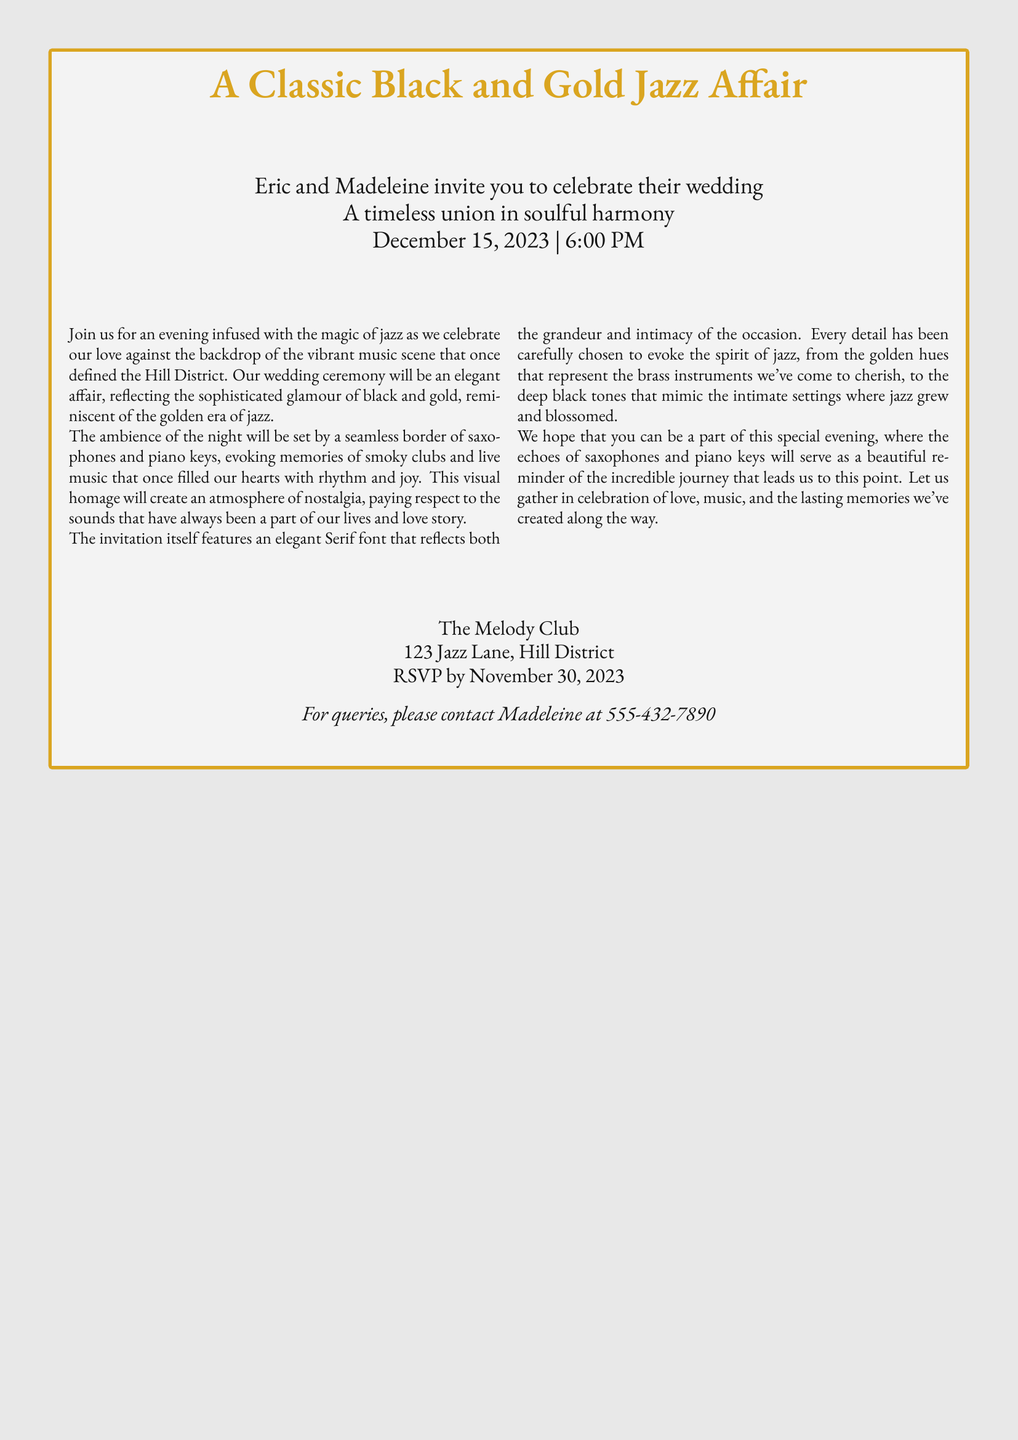What is the date of the wedding? The date of the wedding is clearly stated in the document as December 15, 2023.
Answer: December 15, 2023 Who are the hosts of the wedding? The names of the hosts are listed in the invitation, which are Eric and Madeleine.
Answer: Eric and Madeleine What time does the wedding ceremony start? The invitation specifies that the ceremony starts at 6:00 PM.
Answer: 6:00 PM What is the location of the wedding? The document mentions that the wedding will take place at The Melody Club, located at 123 Jazz Lane, Hill District.
Answer: The Melody Club, 123 Jazz Lane, Hill District What is the RSVP deadline? The document states that guests should RSVP by November 30, 2023.
Answer: November 30, 2023 What aesthetic theme is reflected in the wedding invitation? The invitation highlights a classic black and gold aesthetic reflecting sophistication and elegance.
Answer: Black and gold What musical instruments are featured in the border design? The images of the saxophones and piano keys are prominently mentioned in the invitation's design.
Answer: Saxophones and piano keys What atmosphere is intended for the evening? The invitation describes an evening infused with the magic of jazz, creating a nostalgic and joyful atmosphere.
Answer: Magical jazz atmosphere 